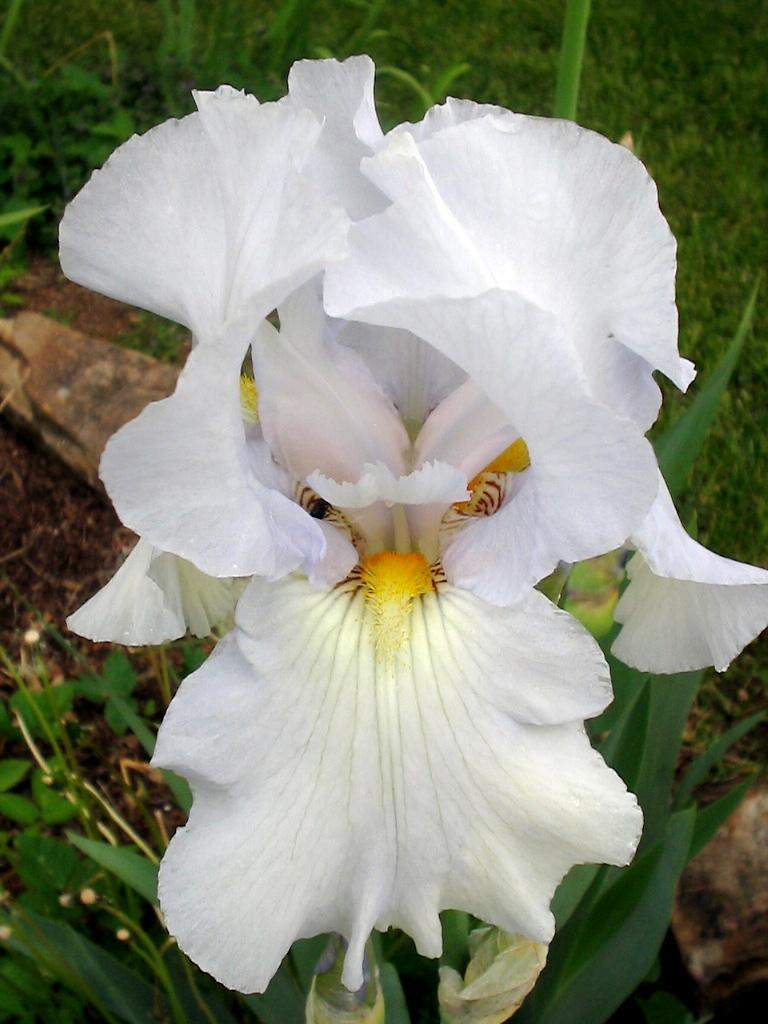What type of flora can be seen in the image? There are flowers in the image. What colors are the flowers? The flowers are in white and yellow colors. What can be seen in the background of the image? There are plants in the background of the image. What color are the plants? The plants are in green color. What type of industry can be seen in the image? There is no industry present in the image; it features flowers and plants. What role does zinc play in the image? Zinc is not mentioned or depicted in the image. 